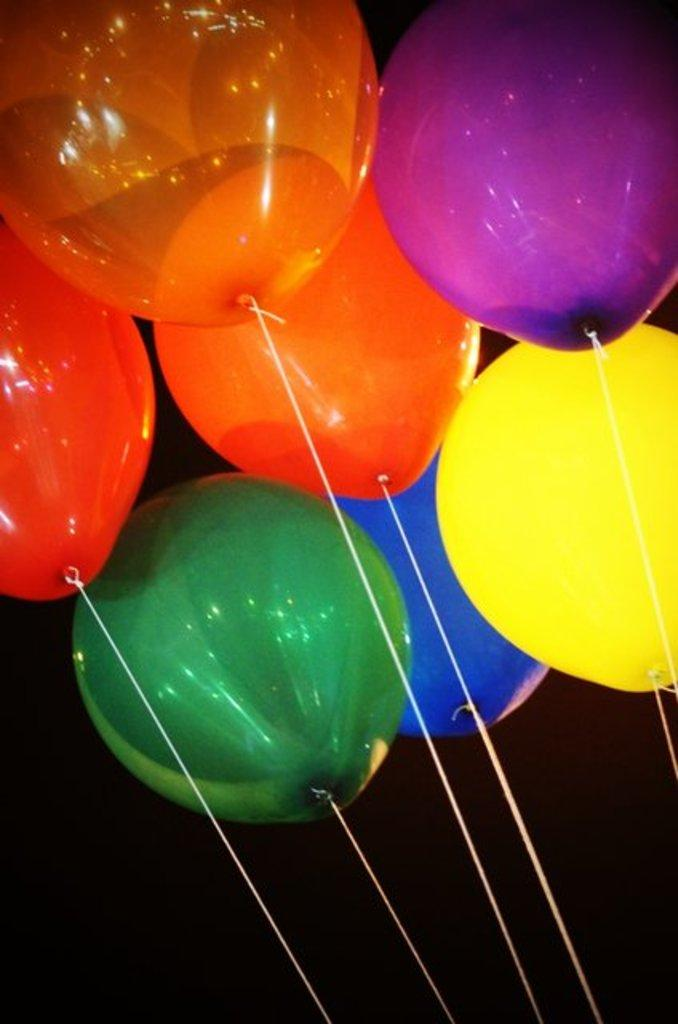What objects are present in the image? There are balloons in the image. Can you describe the balloons in more detail? The balloons are of different colors and are tied with thread. What can be observed about the background of the image? The background of the image is dark. What type of creature can be seen shopping at the market in the image? There is no creature or market present in the image; it features balloons of different colors tied with thread against a dark background. 